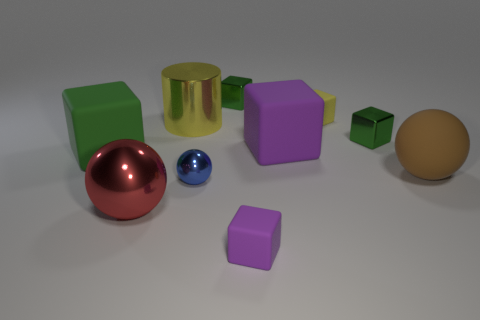Which objects in the image have a matte surface? In this image, the larger green cube, the purple cube, and the tan sphere have a matte surface, which doesn't reflect light as much as the other objects with a metallic or glossy finish. 